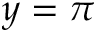<formula> <loc_0><loc_0><loc_500><loc_500>y = \pi</formula> 